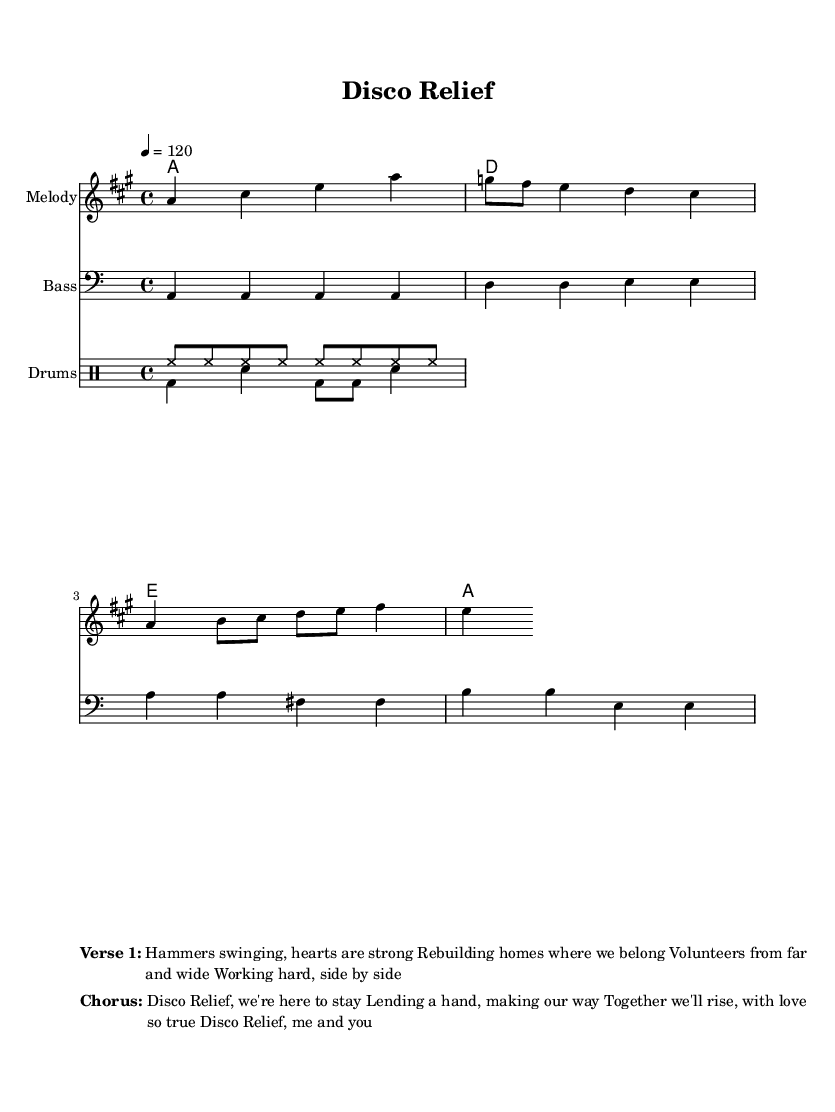What is the key signature of this music? The key signature is A major, indicated by three sharps (F#, C#, and G#) shown at the beginning of the staff.
Answer: A major What is the time signature of this music? The time signature is 4/4, which is represented by the notation seen at the beginning of the piece. This indicates that there are four beats per measure and a quarter note gets one beat.
Answer: 4/4 What is the tempo marking given in the sheet? The tempo marking is quarter note equals 120, which is indicated at the beginning of the score. This means the piece should be played at a speed of 120 beats per minute.
Answer: 120 How many measures are in the melody? There are 4 measures in the melody part, as indicated by the vertical bar lines that delineate the sections of music.
Answer: 4 What style of music is this piece? The style of music is Disco, which is clear from the upbeat tempo, rhythmic bassline, and a focus on dance-friendly melodies typically associated with the disco genre.
Answer: Disco Which lyrics are designated for the chorus? The lyrics for the chorus are "Disco Relief, we're here to stay / Lending a hand, making our way / Together we'll rise, with love so true / Disco Relief, me and you," which is clearly marked in the score.
Answer: Disco Relief, we're here to stay / Lending a hand, making our way / Together we'll rise, with love so true / Disco Relief, me and you 